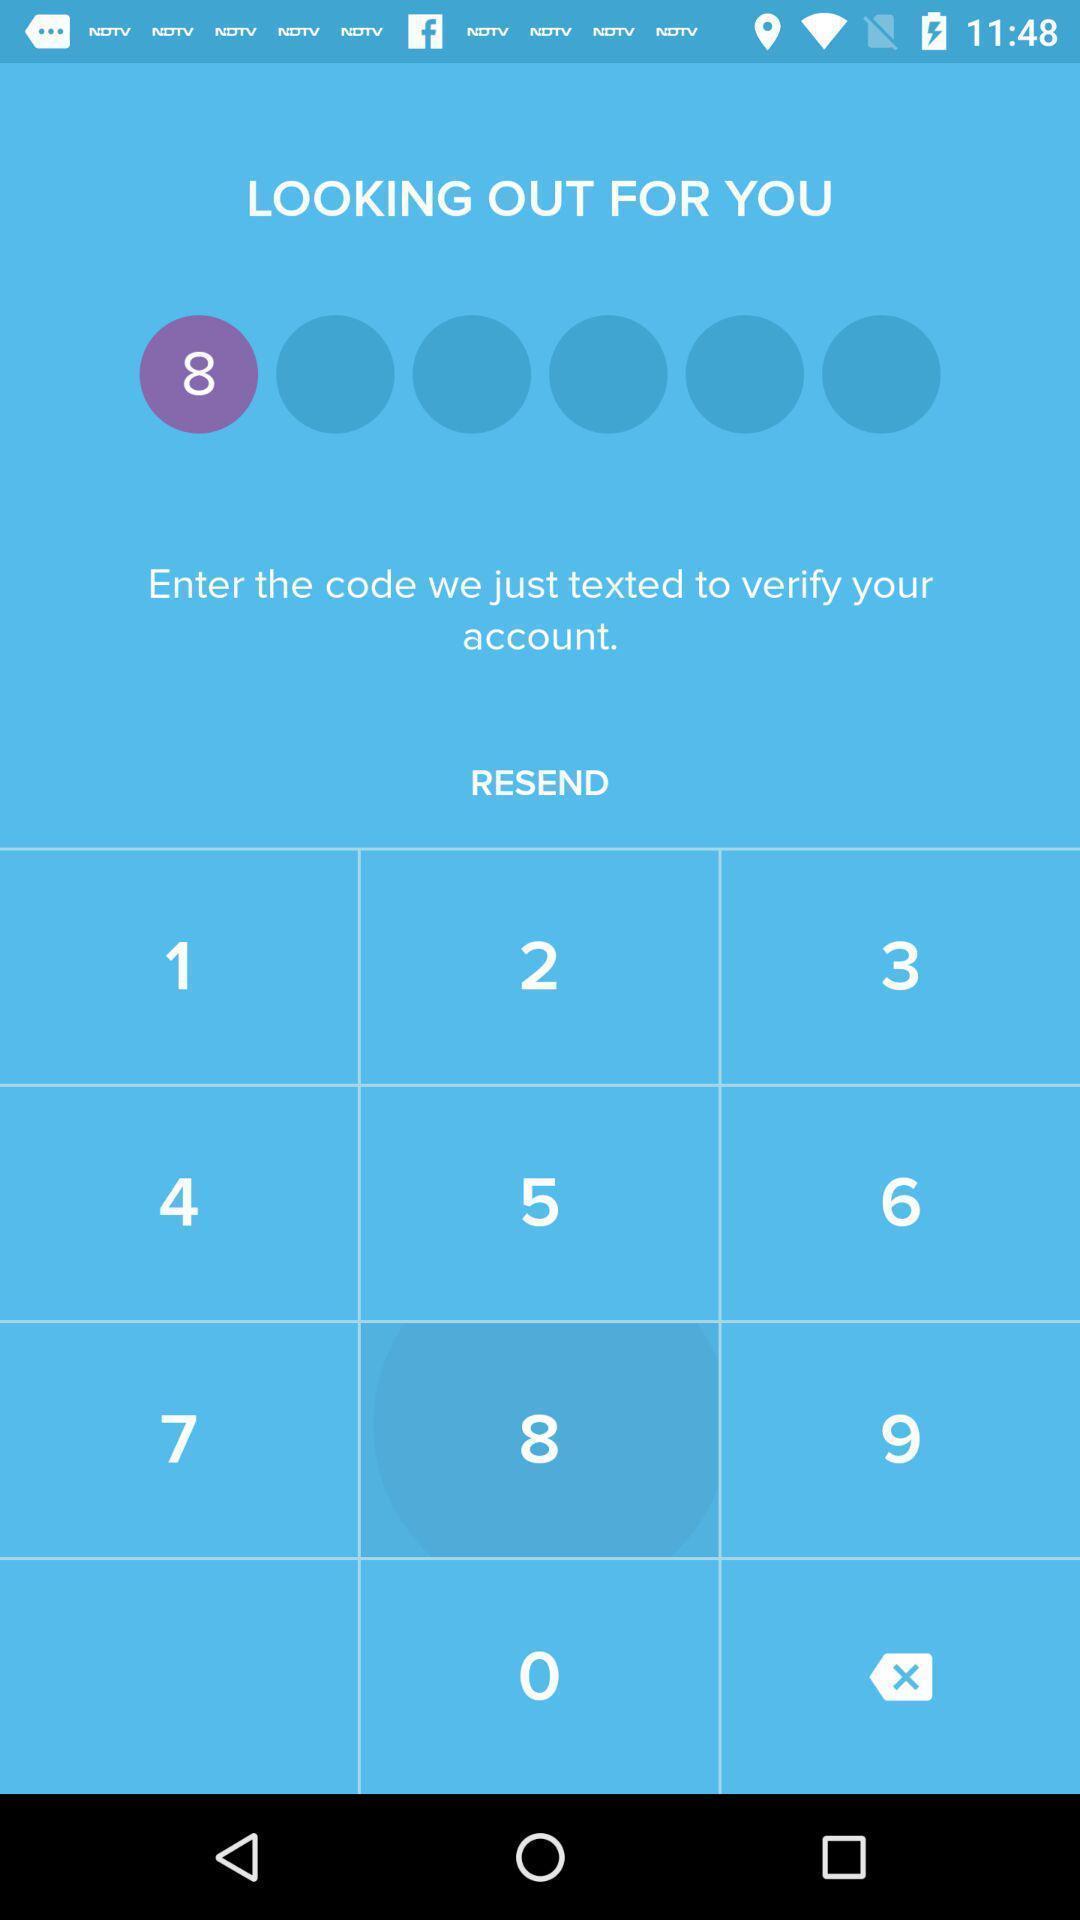Explain the elements present in this screenshot. Screen displaying multiple options in verification page. 